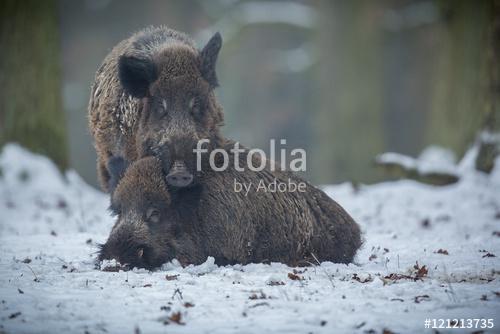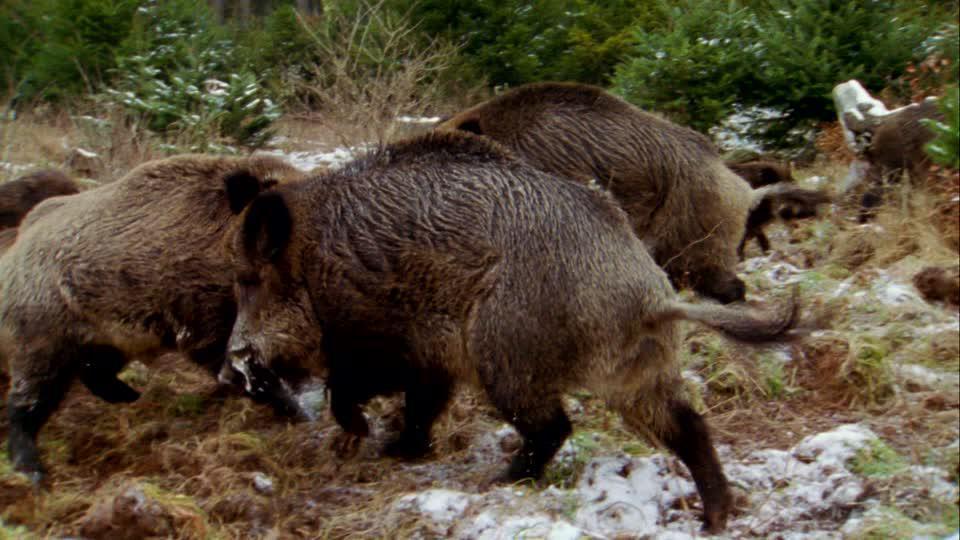The first image is the image on the left, the second image is the image on the right. Evaluate the accuracy of this statement regarding the images: "The right image shows at least three boars.". Is it true? Answer yes or no. Yes. 